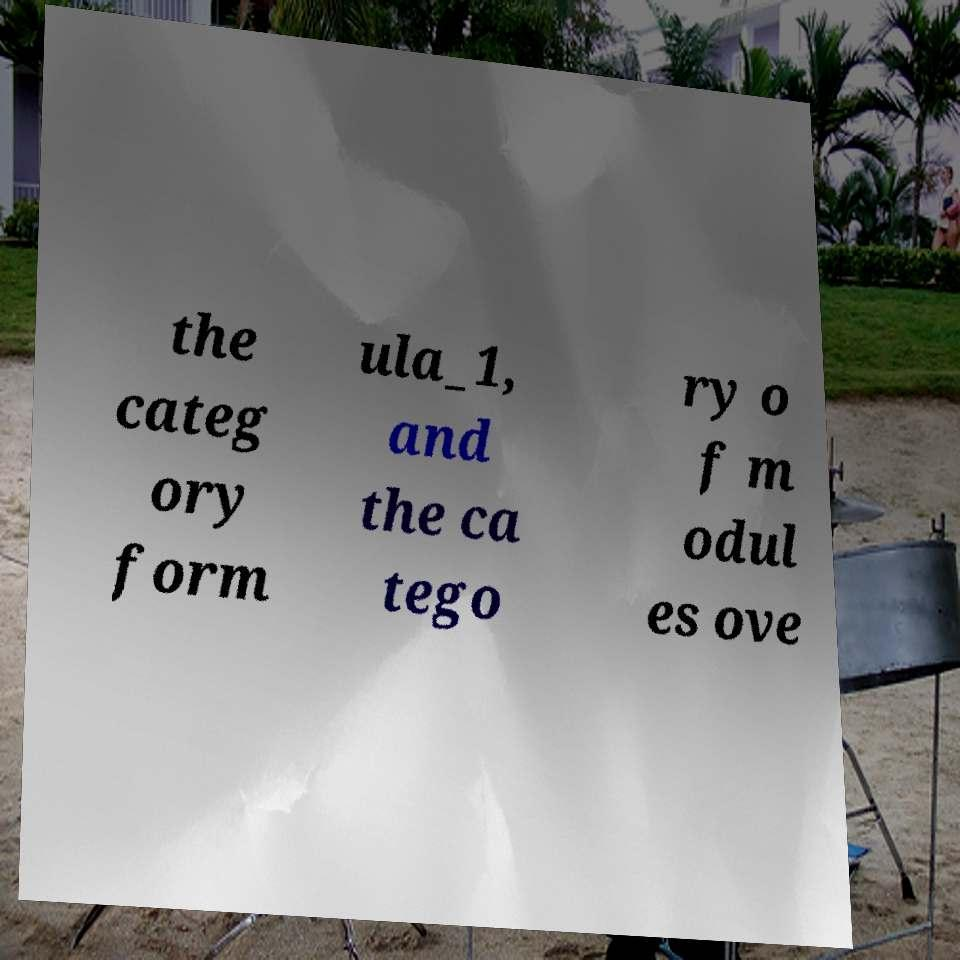Can you read and provide the text displayed in the image?This photo seems to have some interesting text. Can you extract and type it out for me? the categ ory form ula_1, and the ca tego ry o f m odul es ove 